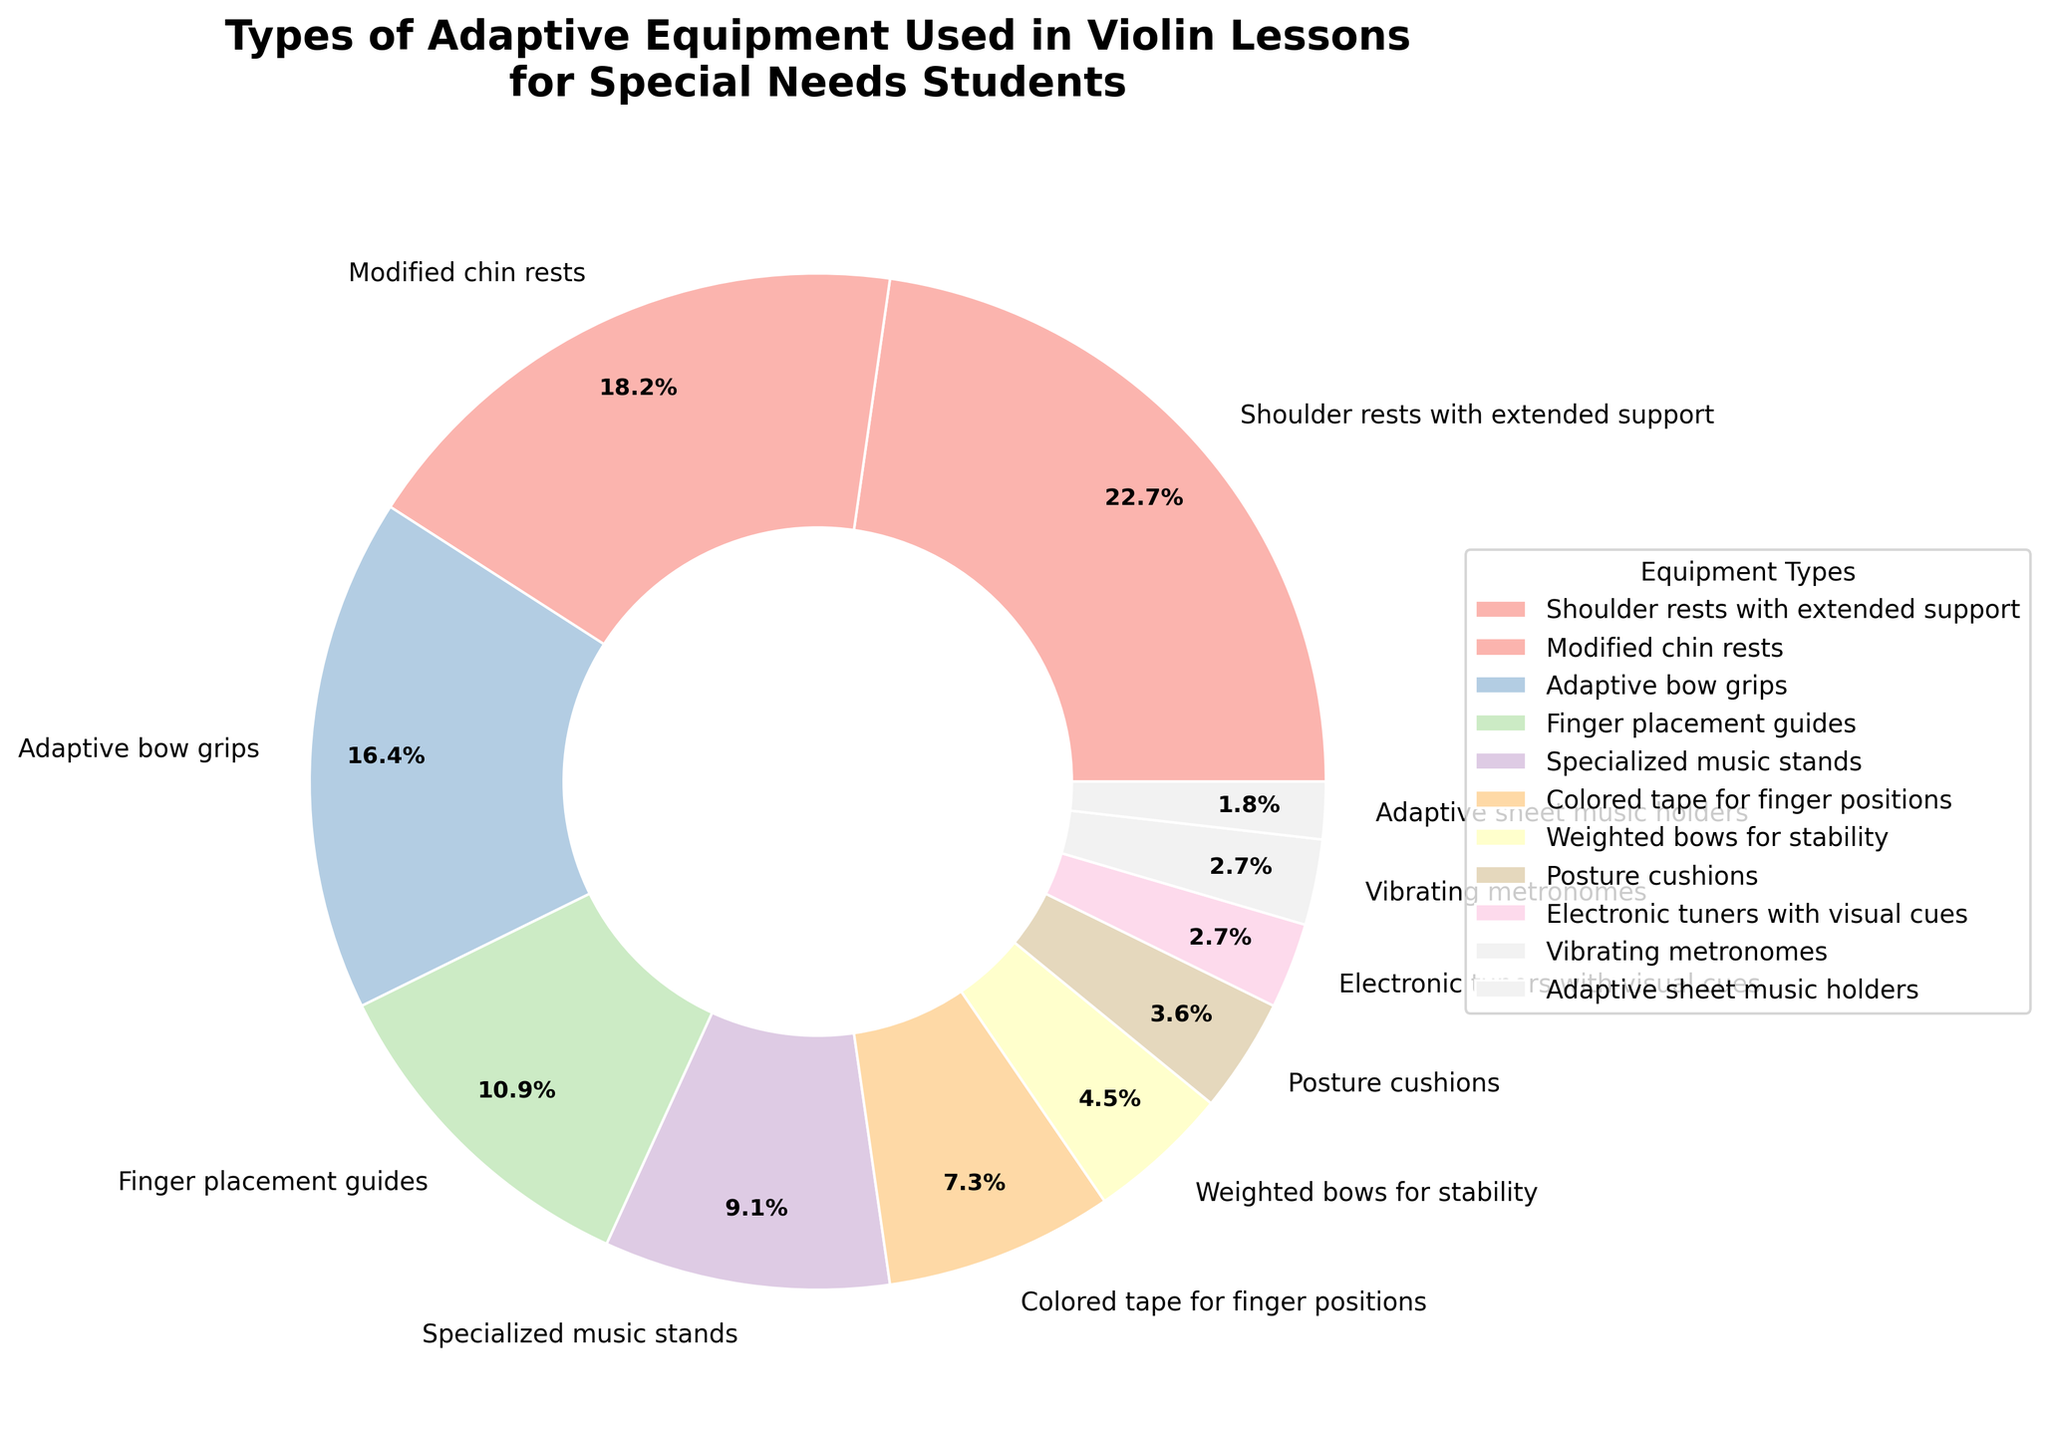Which type of adaptive equipment is used the most in violin lessons for students with special needs? Look for the category with the largest percentage. "Shoulder rests with extended support" have the highest percentage at 25%.
Answer: Shoulder rests with extended support What percentage of adaptive equipment categories have a percentage greater than 10%? Count the number of categories with percentages above 10%. The categories include "Shoulder rests with extended support", "Modified chin rests", "Adaptive bow grips", and "Finger placement guides" (4 categories out of 11).
Answer: 36.36% Which two types of adaptive equipment have the smallest percentages, and what are those percentages? Identify the two categories with the smallest slices. "Adaptive sheet music holders" and "Vibrating metronomes" are the smallest, each with 2% and 3% respectively.
Answer: Adaptive sheet music holders (2%), Vibrating metronomes (3%) Which categories combined make up exactly 50% of the total? Add the percentages of the largest categories until you reach or exceed 50%. The categories "Shoulder rests with extended support" (25%) and "Modified chin rests" (20%) add up to 45%. Adding "Adaptive bow grips" (18%) exceeds 50%. So, it's "Shoulder rests with extended support" and "Modified chin rests".
Answer: Shoulder rests with extended support and Modified chin rests Is the percentage of "Finger placement guides" more than double that of "Weighted bows for stability"? Compare the percentages directly. "Finger placement guides" have 12% and "Weighted bows for stability" have 5%. Since 5% doubled equals 10%, 12% is indeed more than double 5%.
Answer: Yes What is the combined percentage of "Colored tape for finger positions" and "Electronic tuners with visual cues"? Add the percentages of both categories. "Colored tape for finger positions" is 8% and "Electronic tuners with visual cues" is 3%. Therefore, 8% + 3% = 11%.
Answer: 11% How many types of adaptive equipment have a percentage that is less than the average percentage of all categories? First, calculate the average percentage. There are 11 categories, so the average percentage is (100%/11 = 9.1%). Count the categories less than 9.1%: "Colored tape for finger positions", "Weighted bows for stability", "Posture cushions", "Electronic tuners with visual cues", "Vibrating metronomes", "Adaptive sheet music holders" (these 6 are less than 9.1%).
Answer: 6 What is the difference in percentage between "Modified chin rests" and "Specialized music stands"? Subtract the smaller percentage from the larger. "Modified chin rests" (20%) and "Specialized music stands" (10%). Difference = 20% - 10% = 10%.
Answer: 10% Between which pairs of categories is there a 10% difference in their usage? Identify pairs with exactly a 10% difference. The pairs are "Shoulder rests with extended support" (25%) and "Finger placement guides" (12%); "Modified chin rests" (20%) and "Specialized music stands" (10%).
Answer: Shoulder rests with extended support and Finger placement guides, Modified chin rests and Specialized music stands 